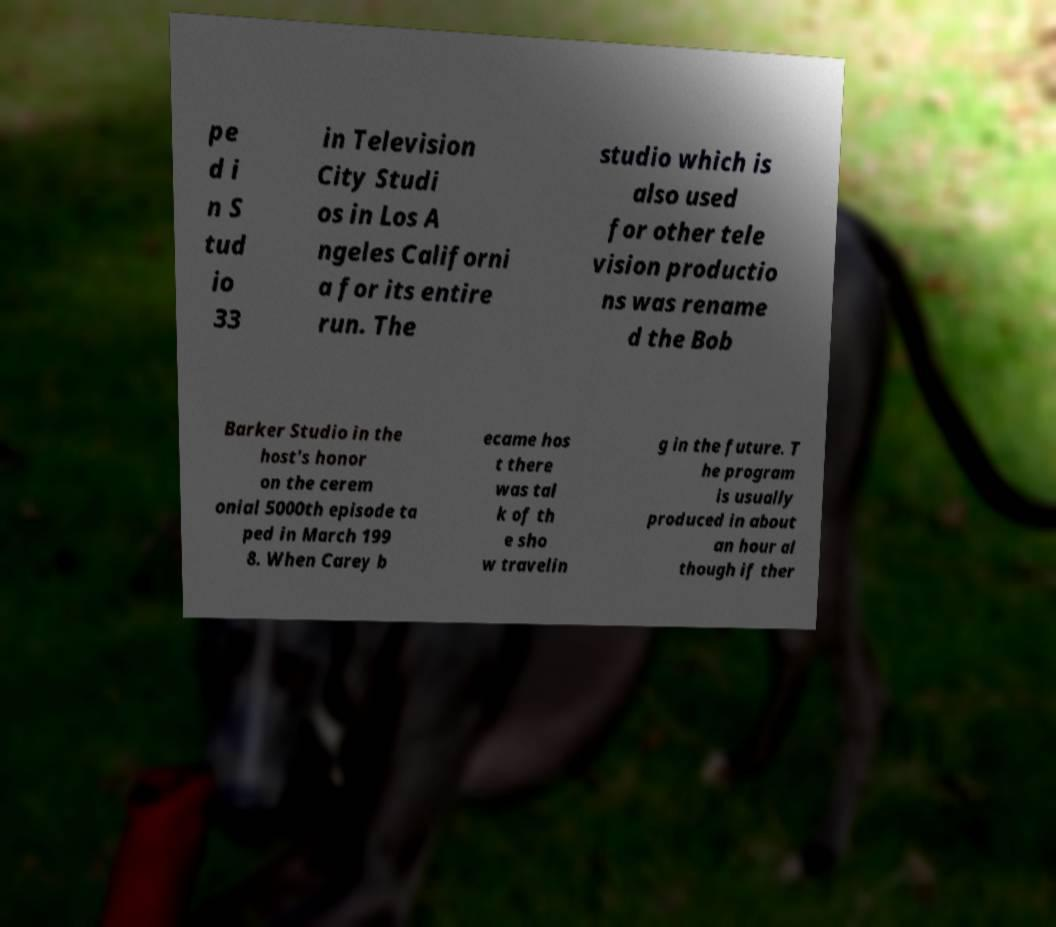Can you accurately transcribe the text from the provided image for me? pe d i n S tud io 33 in Television City Studi os in Los A ngeles Californi a for its entire run. The studio which is also used for other tele vision productio ns was rename d the Bob Barker Studio in the host's honor on the cerem onial 5000th episode ta ped in March 199 8. When Carey b ecame hos t there was tal k of th e sho w travelin g in the future. T he program is usually produced in about an hour al though if ther 